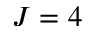<formula> <loc_0><loc_0><loc_500><loc_500>J = 4</formula> 